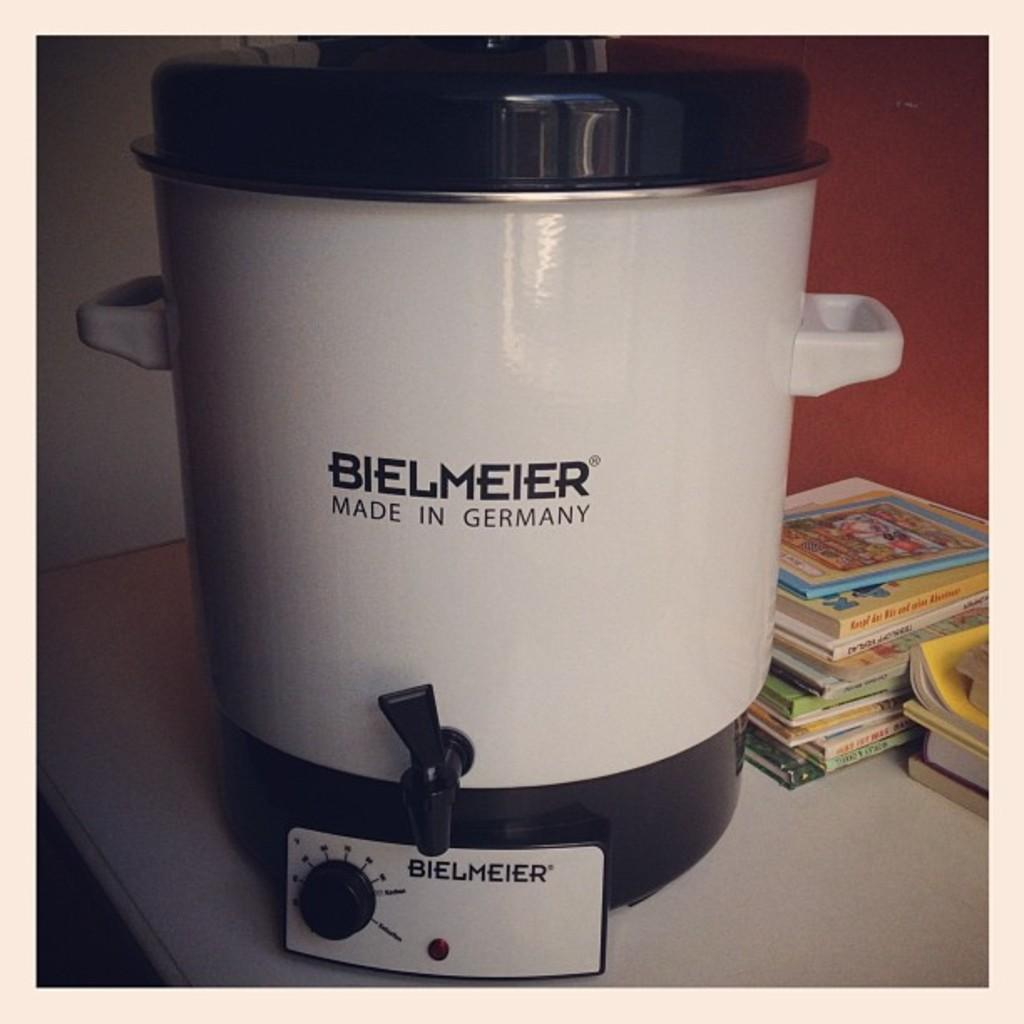<image>
Offer a succinct explanation of the picture presented. A white Bielmeier pressure cooker made in Germany. 